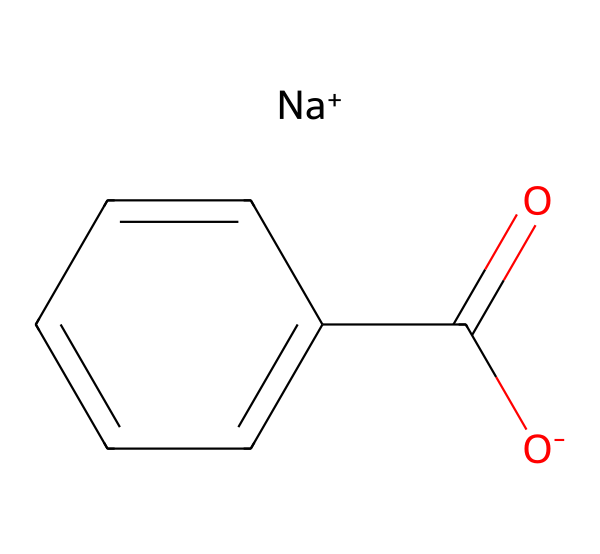What is the main functional group in sodium benzoate? The functional group in sodium benzoate is the carboxylate ion, represented by the CO2- part of the structure, indicating it is a salt derived from benzoic acid.
Answer: carboxylate How many carbon atoms are present in sodium benzoate? The structure shows six carbon atoms in the aromatic ring and one in the carboxylate group, totaling seven carbon atoms.
Answer: seven What type of ion is present in sodium benzoate? The structure has a sodium ion (Na+) as well as a negatively charged carboxylate, indicating that sodium benzoate is a salt.
Answer: salt How many oxygen atoms are in sodium benzoate? Analyzing the structure reveals two oxygen atoms, one from the carboxylate group (O-) and another as part of the carbonyl (C=O) group.
Answer: two What is the name of the compound represented by this SMILES? The SMILES structure describes sodium benzoate, a sodium salt of benzoic acid, commonly used as a preservative in food.
Answer: sodium benzoate What property makes sodium benzoate useful as a preservative? Sodium benzoate is effective because it inhibits the growth of mold, yeast, and some bacteria, allowing for longer shelf life of food products.
Answer: antimicrobial Which part of the chemical structure contributes to its preservative function? The carboxylate group is integral as it interacts with microbial membranes, leading to growth inhibition, thereby demonstrating its preservative efficacy.
Answer: carboxylate group 